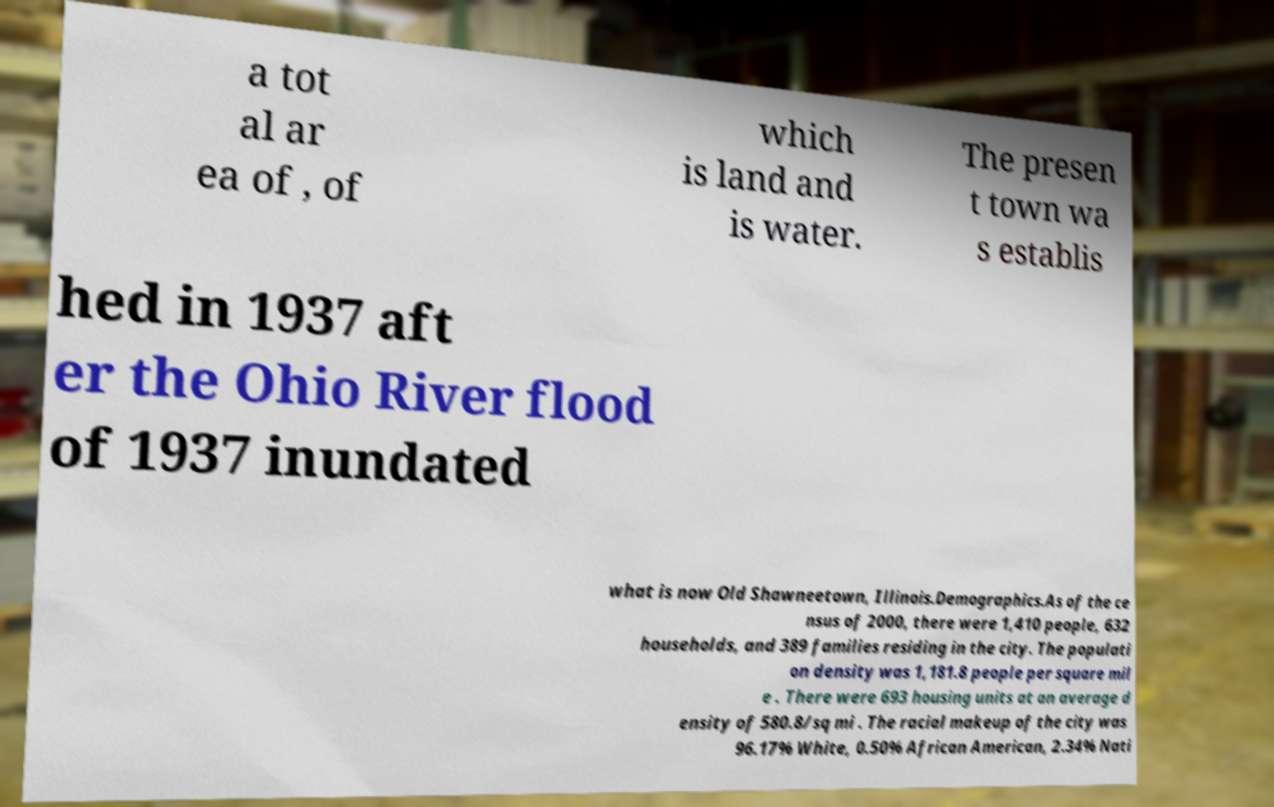Please identify and transcribe the text found in this image. a tot al ar ea of , of which is land and is water. The presen t town wa s establis hed in 1937 aft er the Ohio River flood of 1937 inundated what is now Old Shawneetown, Illinois.Demographics.As of the ce nsus of 2000, there were 1,410 people, 632 households, and 389 families residing in the city. The populati on density was 1,181.8 people per square mil e . There were 693 housing units at an average d ensity of 580.8/sq mi . The racial makeup of the city was 96.17% White, 0.50% African American, 2.34% Nati 